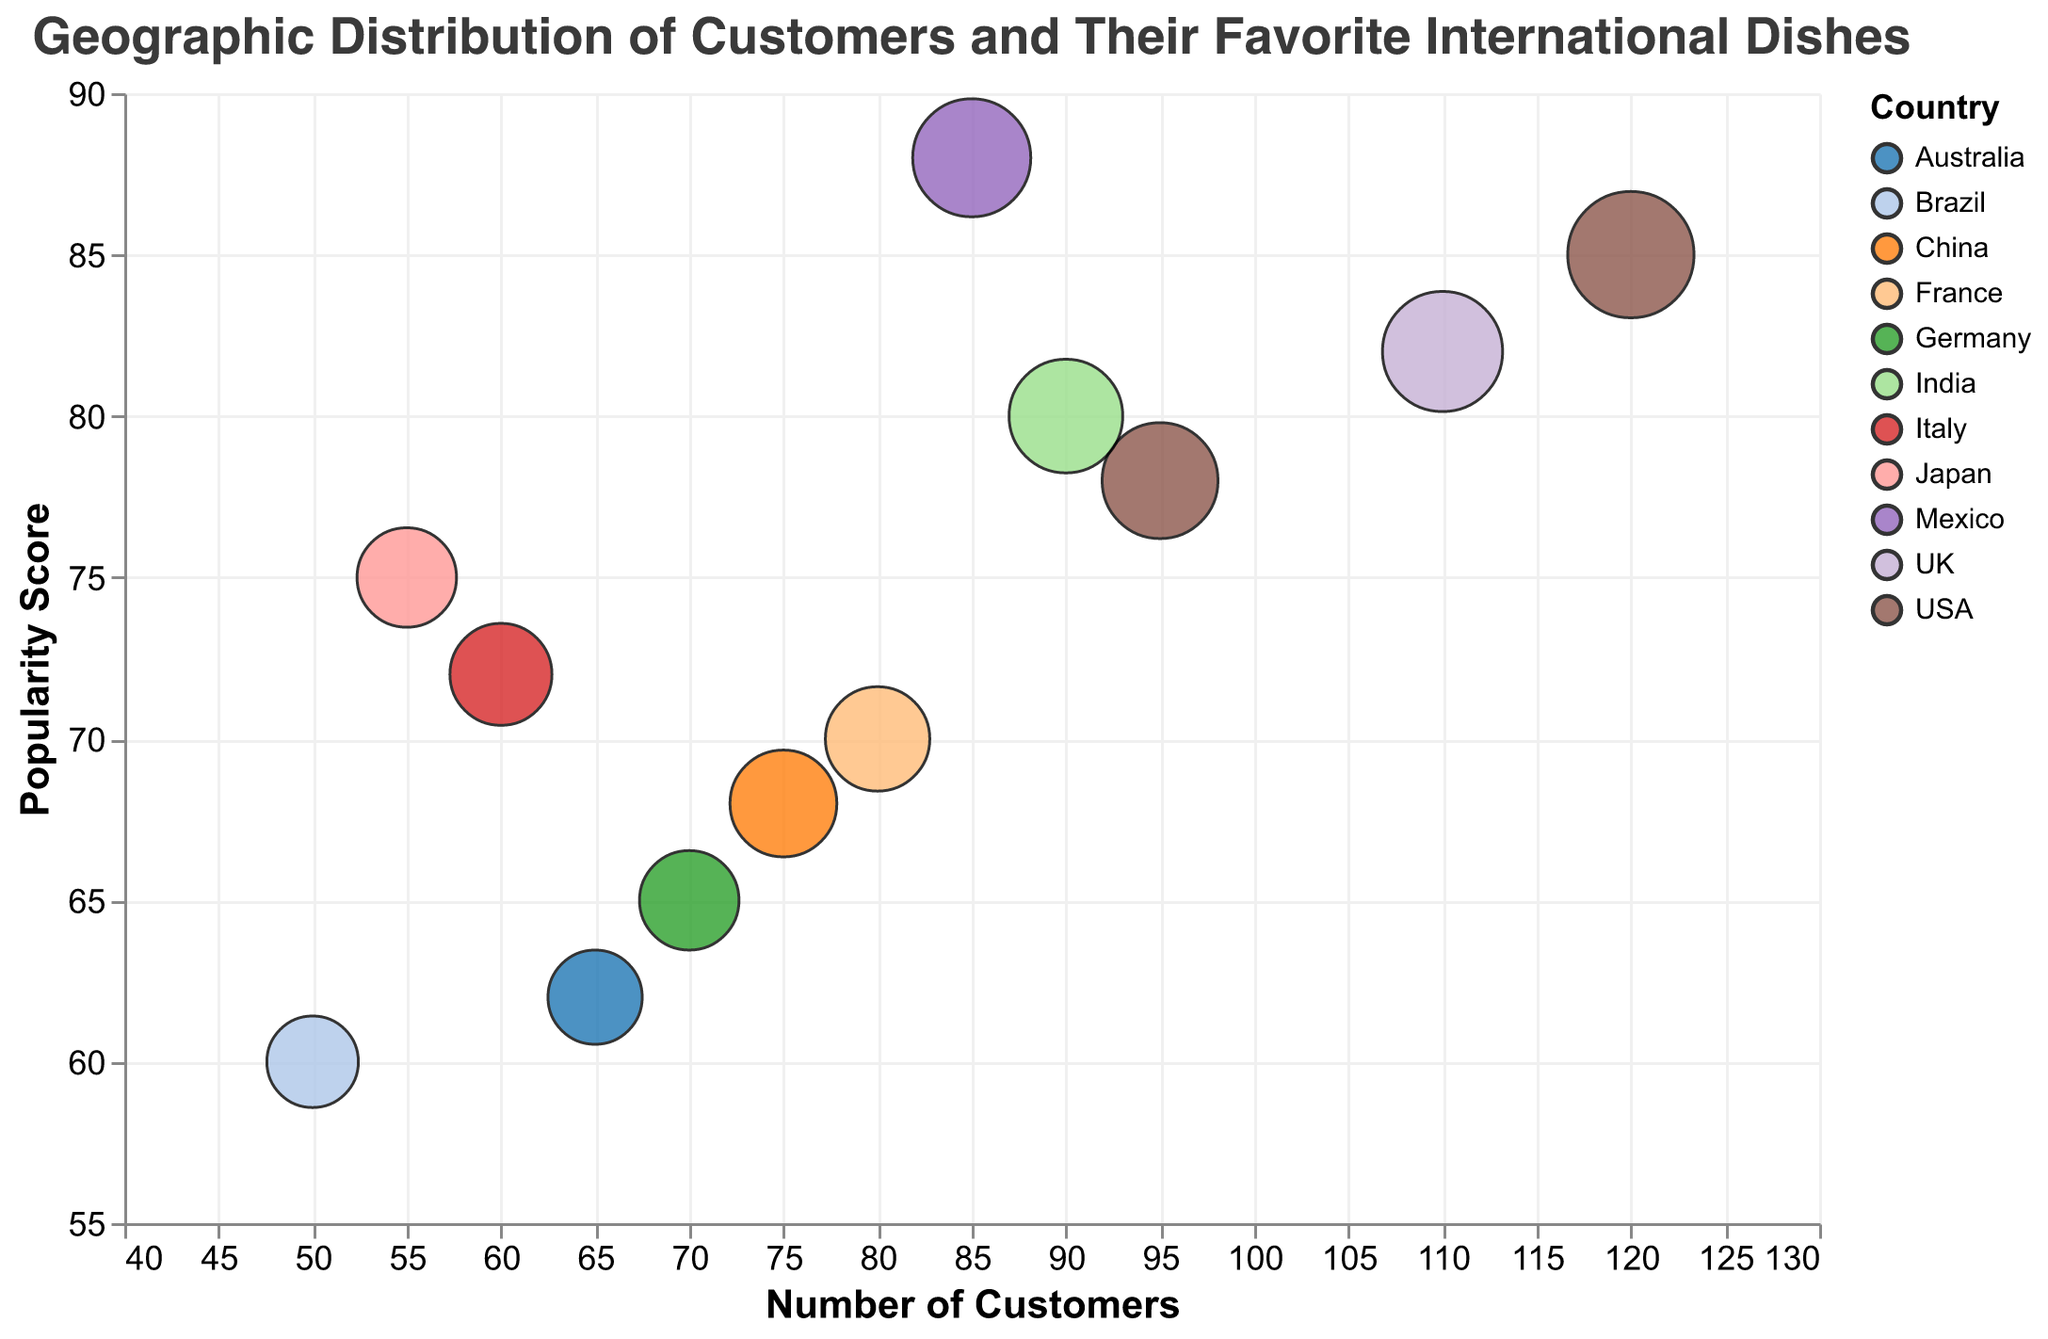What is the title of the figure? The text at the top center of the figure mentions its title, "Geographic Distribution of Customers and Their Favorite International Dishes".
Answer: Geographic Distribution of Customers and Their Favorite International Dishes Which country has the dish with the highest popularity score? By looking at the y-axis and identifying the highest bubble, Mexico City has the dish "Tacos" with a popularity score of 88.
Answer: Mexico Which city has the highest number of customers? The x-axis represents the number of customers, and the furthest bubble to the right is New York with 120 customers.
Answer: New York What is the bubble size for "Margherita Pizza" in Rome, Italy? The tooltip shows the bubble size for the dish "Margherita Pizza" as 190 when hovering over Rome's bubble.
Answer: 190 How many countries are represented in the figure? The legend lists the countries, and there are 12 unique colors/countries in the figure.
Answer: 12 Which city has a dish with a popularity score greater than 80 but fewer than 100 customers? Filtering through the data points reveals only London with "Chicken Tikka Masala" having a popularity score of 82 and 110 customers.
Answer: London What is the average popularity score of the dishes listed? Adding up all popularity scores: 85, 78, 70, 65, 82, 72, 75, 88, 80, 68, 60, 62 and dividing by 12 (the number of data points) gives (85+78+70+65+82+72+75+88+80+68+60+62)/12 = 73.
Answer: 73 Which dish has a popularity score closest to 75? By inspecting the y-axis, "Ramen" in Tokyo, Japan has a popularity score of 75.
Answer: Ramen What is the combined number of customers from New York, Los Angeles, and London? Adding up the customer counts from these cities: New York (120), Los Angeles (95), and London (110), results in 120 + 95 + 110 = 325.
Answer: 325 Which city has the smallest bubble size? Hovering over the smallest bubble size in the figure reveals Rio de Janeiro with a bubble size of 150 for the dish "Feijoada".
Answer: Rio de Janeiro 